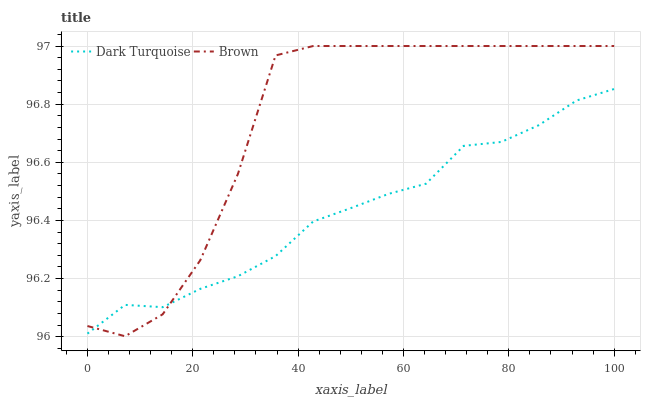Does Brown have the minimum area under the curve?
Answer yes or no. No. Is Brown the smoothest?
Answer yes or no. No. 